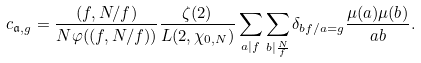Convert formula to latex. <formula><loc_0><loc_0><loc_500><loc_500>c _ { \mathfrak { a } , g } = \frac { ( f , N / f ) } { N \varphi ( ( f , N / f ) ) } \frac { \zeta ( 2 ) } { L ( 2 , \chi _ { 0 , N } ) } \sum _ { a | f } \sum _ { b | \frac { N } { f } } \delta _ { b f / a = g } \frac { \mu ( a ) \mu ( b ) } { a b } .</formula> 